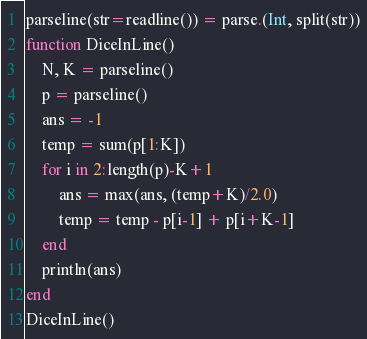<code> <loc_0><loc_0><loc_500><loc_500><_Julia_>parseline(str=readline()) = parse.(Int, split(str))
function DiceInLine()
    N, K = parseline()
    p = parseline()
    ans = -1
    temp = sum(p[1:K])
    for i in 2:length(p)-K+1
        ans = max(ans, (temp+K)/2.0)
        temp = temp - p[i-1] + p[i+K-1]
    end
    println(ans)
end
DiceInLine()</code> 